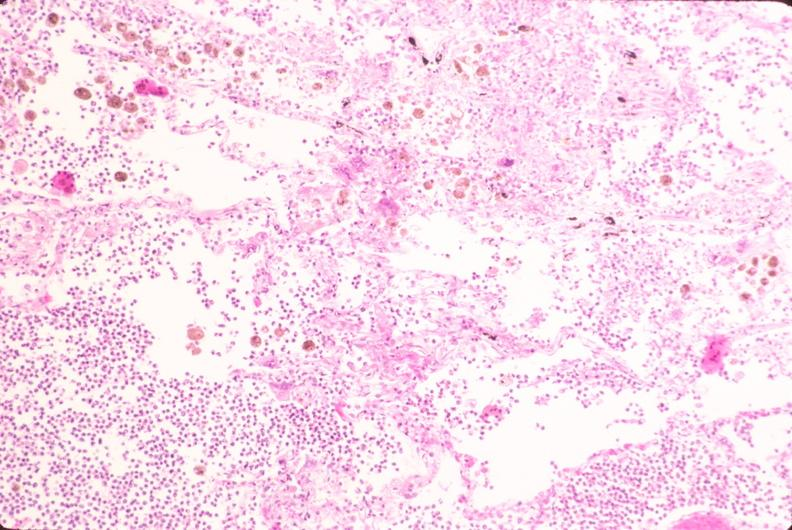does this image show lung, bronchopneumonia, bacterial?
Answer the question using a single word or phrase. Yes 